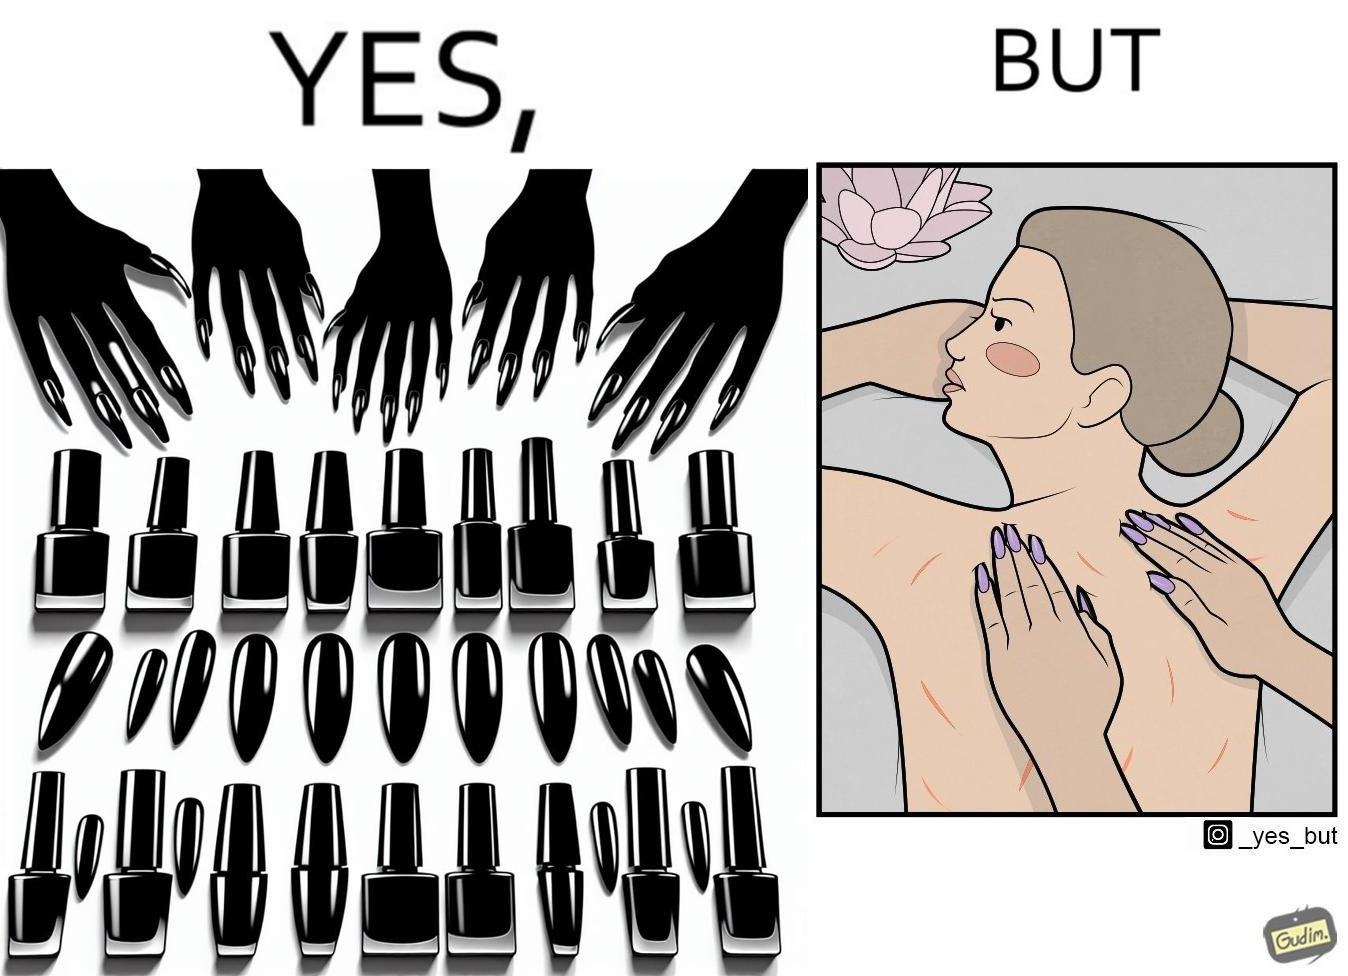Provide a description of this image. The images are funny since it shows that even though the polished and colorful long nails look pretty and fashionable, the hinder the masseuse's ability to do her job of providing relaxing massages and hurts her customers 